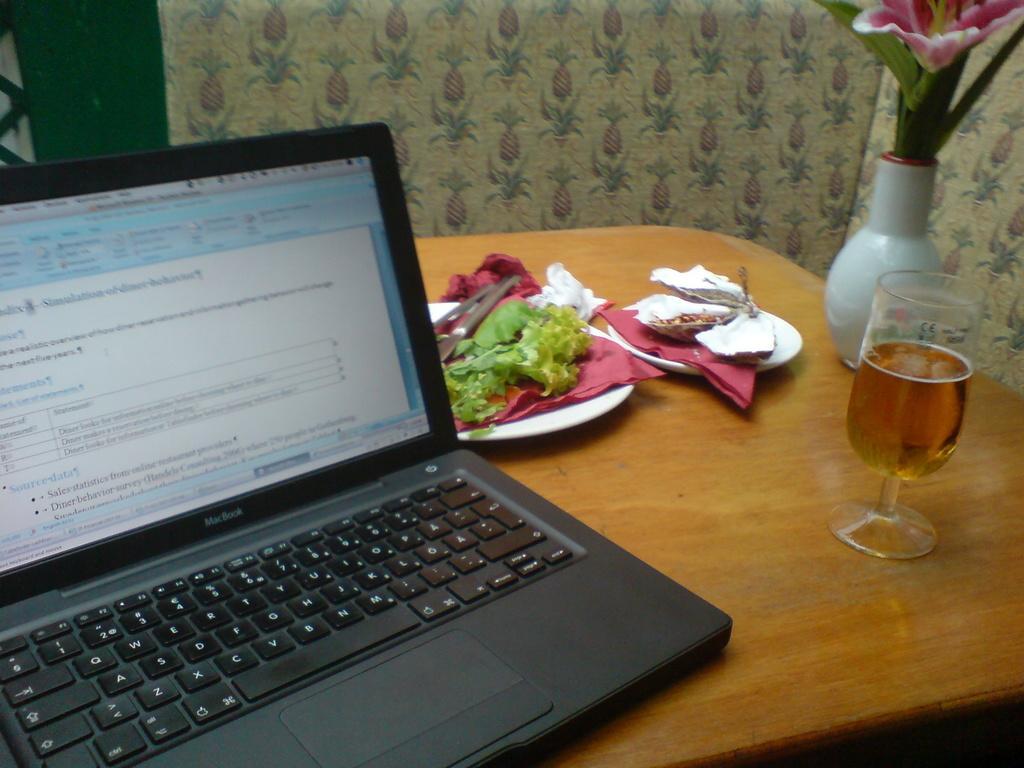Can you describe this image briefly? On this table we can able to see a flowers with vase, glass with liquid, plates, laptop and food. 